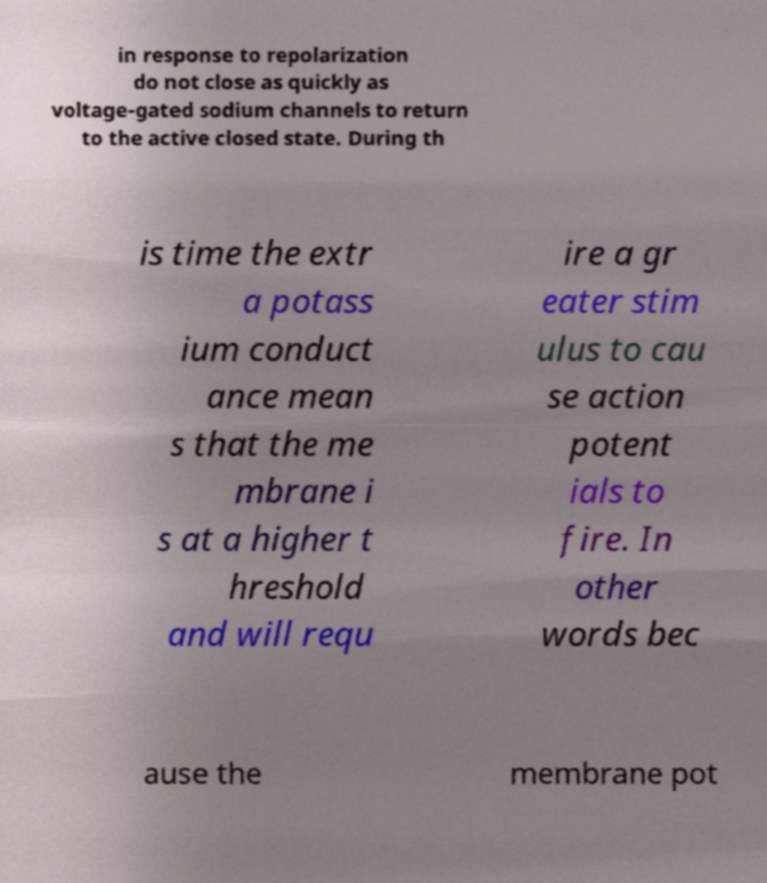There's text embedded in this image that I need extracted. Can you transcribe it verbatim? in response to repolarization do not close as quickly as voltage-gated sodium channels to return to the active closed state. During th is time the extr a potass ium conduct ance mean s that the me mbrane i s at a higher t hreshold and will requ ire a gr eater stim ulus to cau se action potent ials to fire. In other words bec ause the membrane pot 